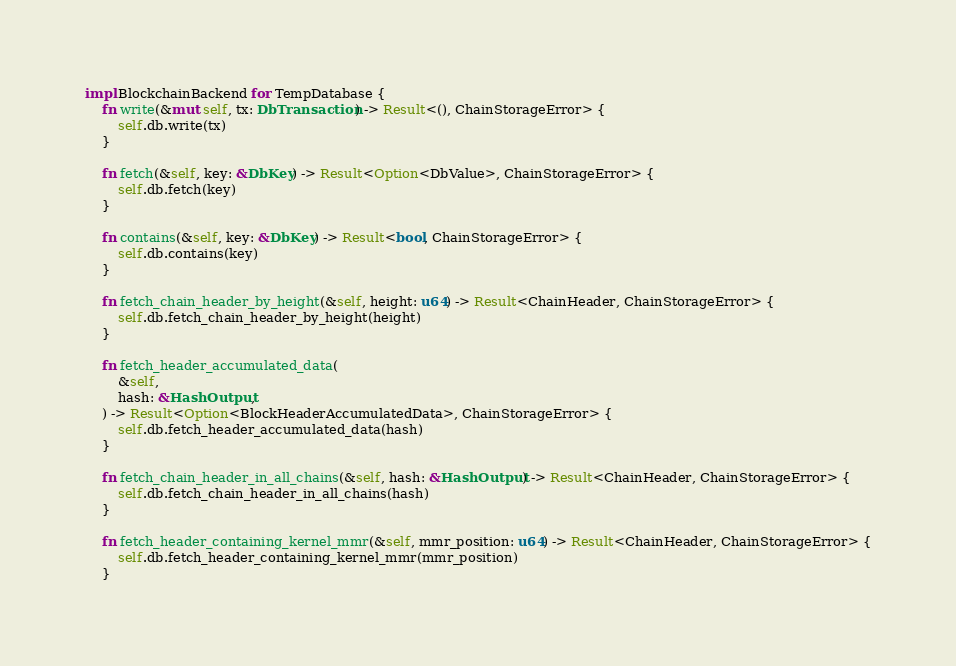<code> <loc_0><loc_0><loc_500><loc_500><_Rust_>impl BlockchainBackend for TempDatabase {
    fn write(&mut self, tx: DbTransaction) -> Result<(), ChainStorageError> {
        self.db.write(tx)
    }

    fn fetch(&self, key: &DbKey) -> Result<Option<DbValue>, ChainStorageError> {
        self.db.fetch(key)
    }

    fn contains(&self, key: &DbKey) -> Result<bool, ChainStorageError> {
        self.db.contains(key)
    }

    fn fetch_chain_header_by_height(&self, height: u64) -> Result<ChainHeader, ChainStorageError> {
        self.db.fetch_chain_header_by_height(height)
    }

    fn fetch_header_accumulated_data(
        &self,
        hash: &HashOutput,
    ) -> Result<Option<BlockHeaderAccumulatedData>, ChainStorageError> {
        self.db.fetch_header_accumulated_data(hash)
    }

    fn fetch_chain_header_in_all_chains(&self, hash: &HashOutput) -> Result<ChainHeader, ChainStorageError> {
        self.db.fetch_chain_header_in_all_chains(hash)
    }

    fn fetch_header_containing_kernel_mmr(&self, mmr_position: u64) -> Result<ChainHeader, ChainStorageError> {
        self.db.fetch_header_containing_kernel_mmr(mmr_position)
    }
</code> 